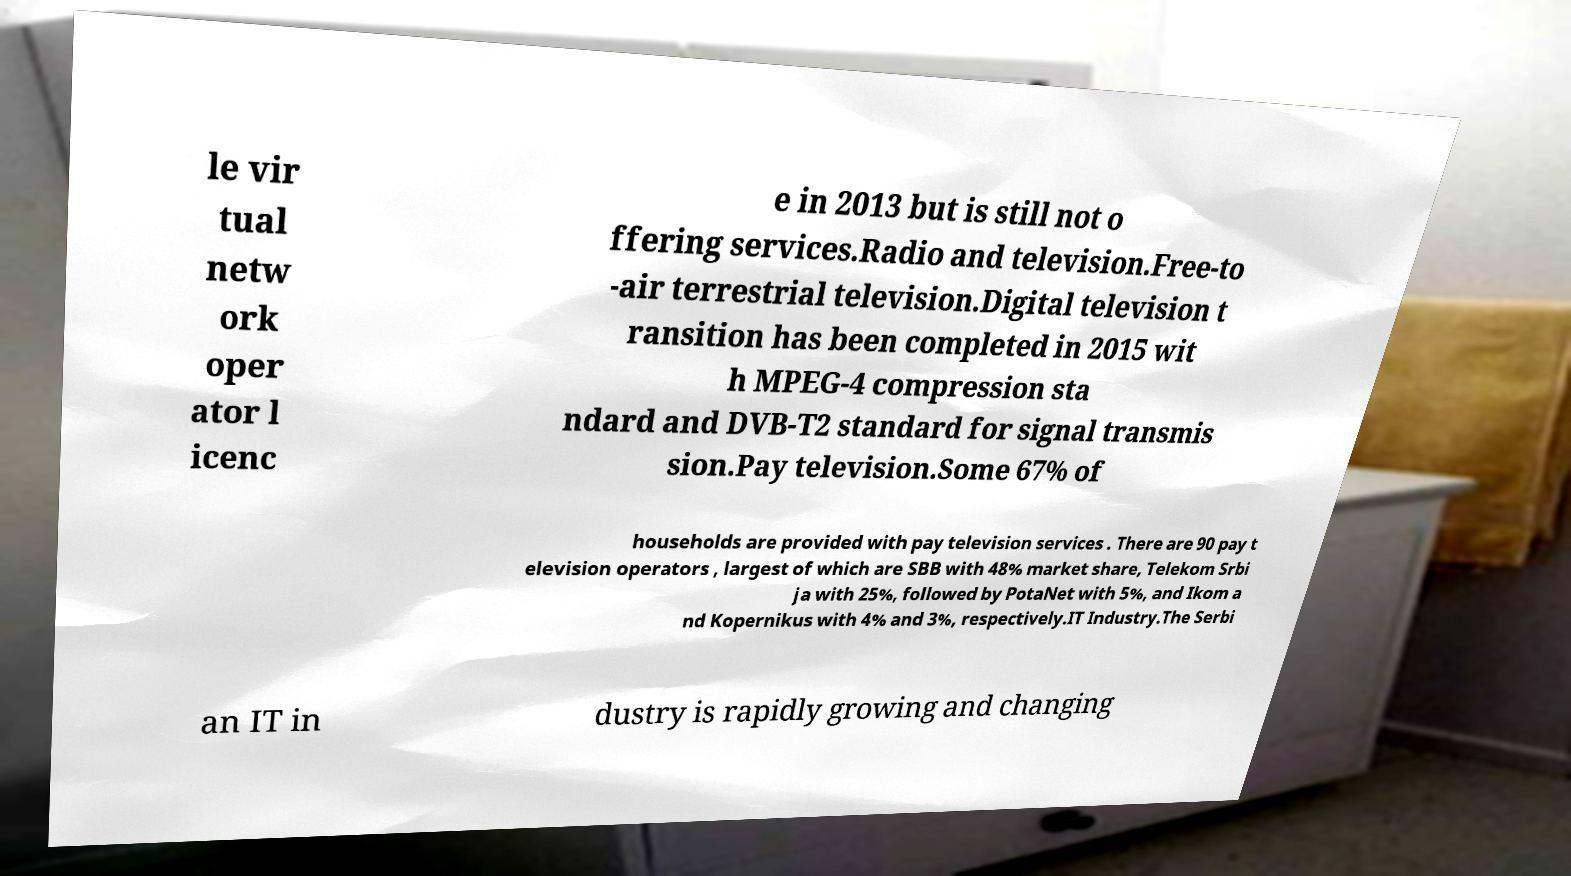Can you read and provide the text displayed in the image?This photo seems to have some interesting text. Can you extract and type it out for me? le vir tual netw ork oper ator l icenc e in 2013 but is still not o ffering services.Radio and television.Free-to -air terrestrial television.Digital television t ransition has been completed in 2015 wit h MPEG-4 compression sta ndard and DVB-T2 standard for signal transmis sion.Pay television.Some 67% of households are provided with pay television services . There are 90 pay t elevision operators , largest of which are SBB with 48% market share, Telekom Srbi ja with 25%, followed by PotaNet with 5%, and Ikom a nd Kopernikus with 4% and 3%, respectively.IT Industry.The Serbi an IT in dustry is rapidly growing and changing 